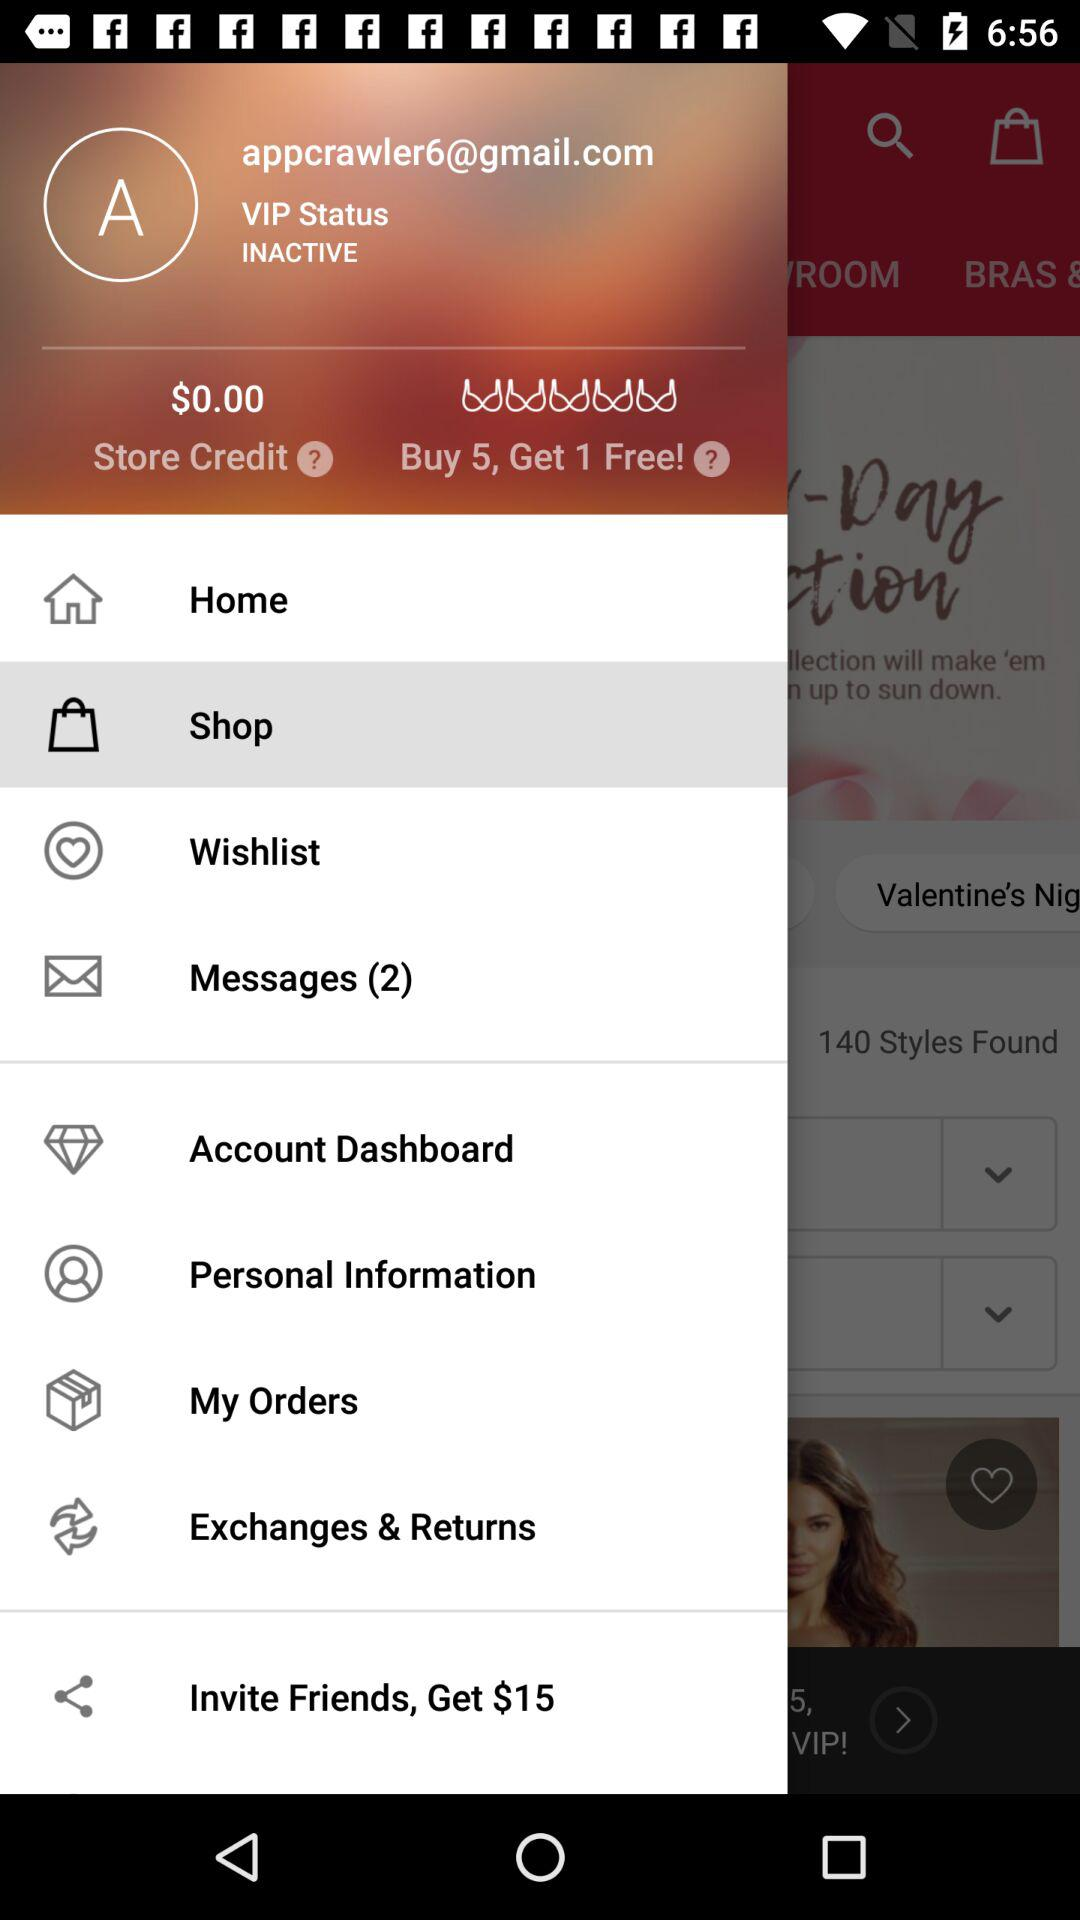What's the VIP status of a user? The status is "INACTIVE". 